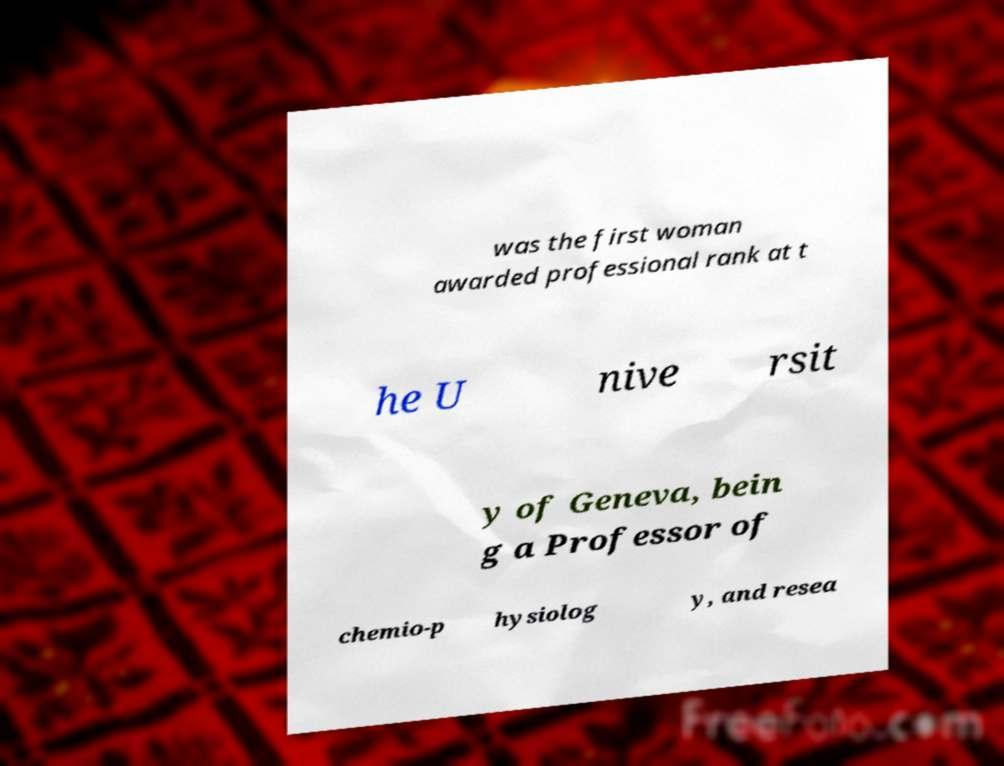Can you accurately transcribe the text from the provided image for me? was the first woman awarded professional rank at t he U nive rsit y of Geneva, bein g a Professor of chemio-p hysiolog y, and resea 